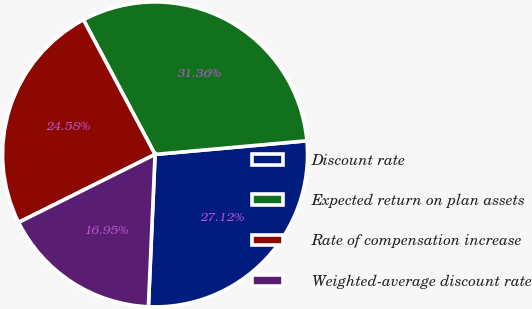Convert chart. <chart><loc_0><loc_0><loc_500><loc_500><pie_chart><fcel>Discount rate<fcel>Expected return on plan assets<fcel>Rate of compensation increase<fcel>Weighted-average discount rate<nl><fcel>27.12%<fcel>31.36%<fcel>24.58%<fcel>16.95%<nl></chart> 